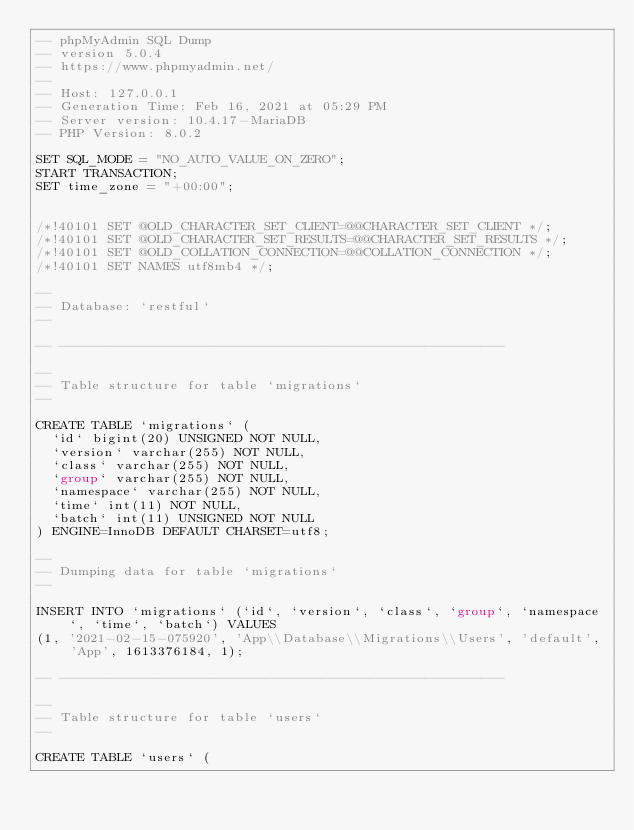Convert code to text. <code><loc_0><loc_0><loc_500><loc_500><_SQL_>-- phpMyAdmin SQL Dump
-- version 5.0.4
-- https://www.phpmyadmin.net/
--
-- Host: 127.0.0.1
-- Generation Time: Feb 16, 2021 at 05:29 PM
-- Server version: 10.4.17-MariaDB
-- PHP Version: 8.0.2

SET SQL_MODE = "NO_AUTO_VALUE_ON_ZERO";
START TRANSACTION;
SET time_zone = "+00:00";


/*!40101 SET @OLD_CHARACTER_SET_CLIENT=@@CHARACTER_SET_CLIENT */;
/*!40101 SET @OLD_CHARACTER_SET_RESULTS=@@CHARACTER_SET_RESULTS */;
/*!40101 SET @OLD_COLLATION_CONNECTION=@@COLLATION_CONNECTION */;
/*!40101 SET NAMES utf8mb4 */;

--
-- Database: `restful`
--

-- --------------------------------------------------------

--
-- Table structure for table `migrations`
--

CREATE TABLE `migrations` (
  `id` bigint(20) UNSIGNED NOT NULL,
  `version` varchar(255) NOT NULL,
  `class` varchar(255) NOT NULL,
  `group` varchar(255) NOT NULL,
  `namespace` varchar(255) NOT NULL,
  `time` int(11) NOT NULL,
  `batch` int(11) UNSIGNED NOT NULL
) ENGINE=InnoDB DEFAULT CHARSET=utf8;

--
-- Dumping data for table `migrations`
--

INSERT INTO `migrations` (`id`, `version`, `class`, `group`, `namespace`, `time`, `batch`) VALUES
(1, '2021-02-15-075920', 'App\\Database\\Migrations\\Users', 'default', 'App', 1613376184, 1);

-- --------------------------------------------------------

--
-- Table structure for table `users`
--

CREATE TABLE `users` (</code> 